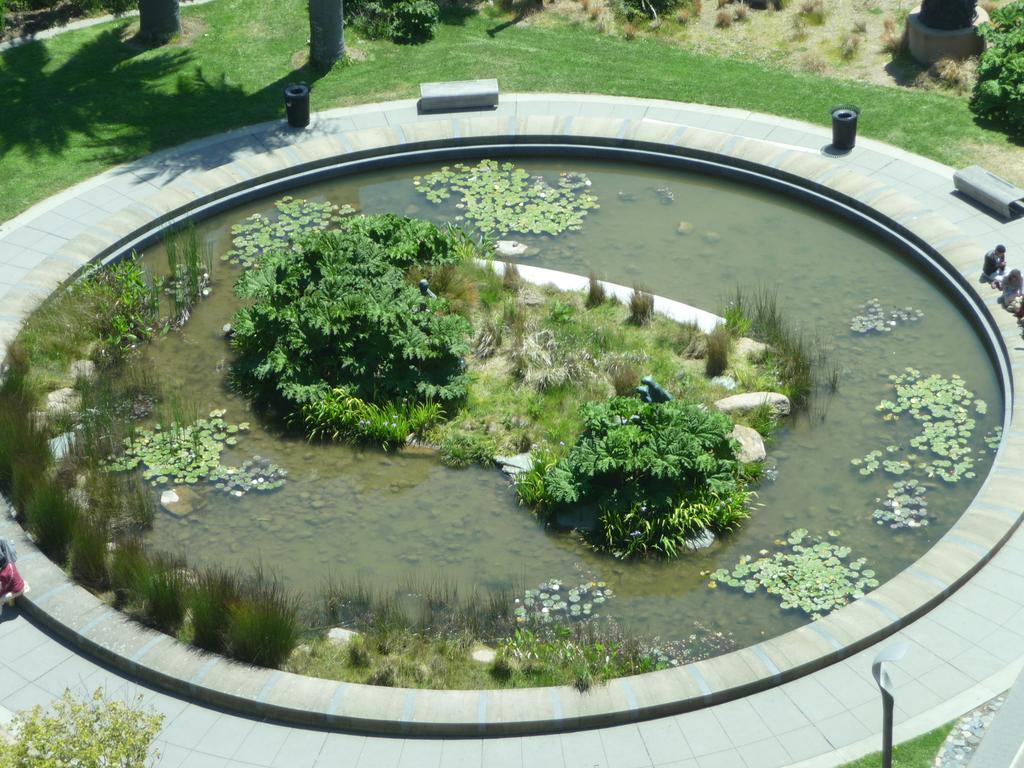Please provide a concise description of this image. In this image we can see the water pond with plants and leaves and there are a few people sitting on the ground. And there are few objects and grass. At the back it looks like a tree trunk. 